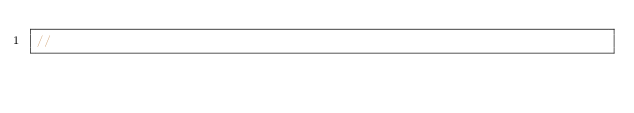Convert code to text. <code><loc_0><loc_0><loc_500><loc_500><_C++_>//

</code> 